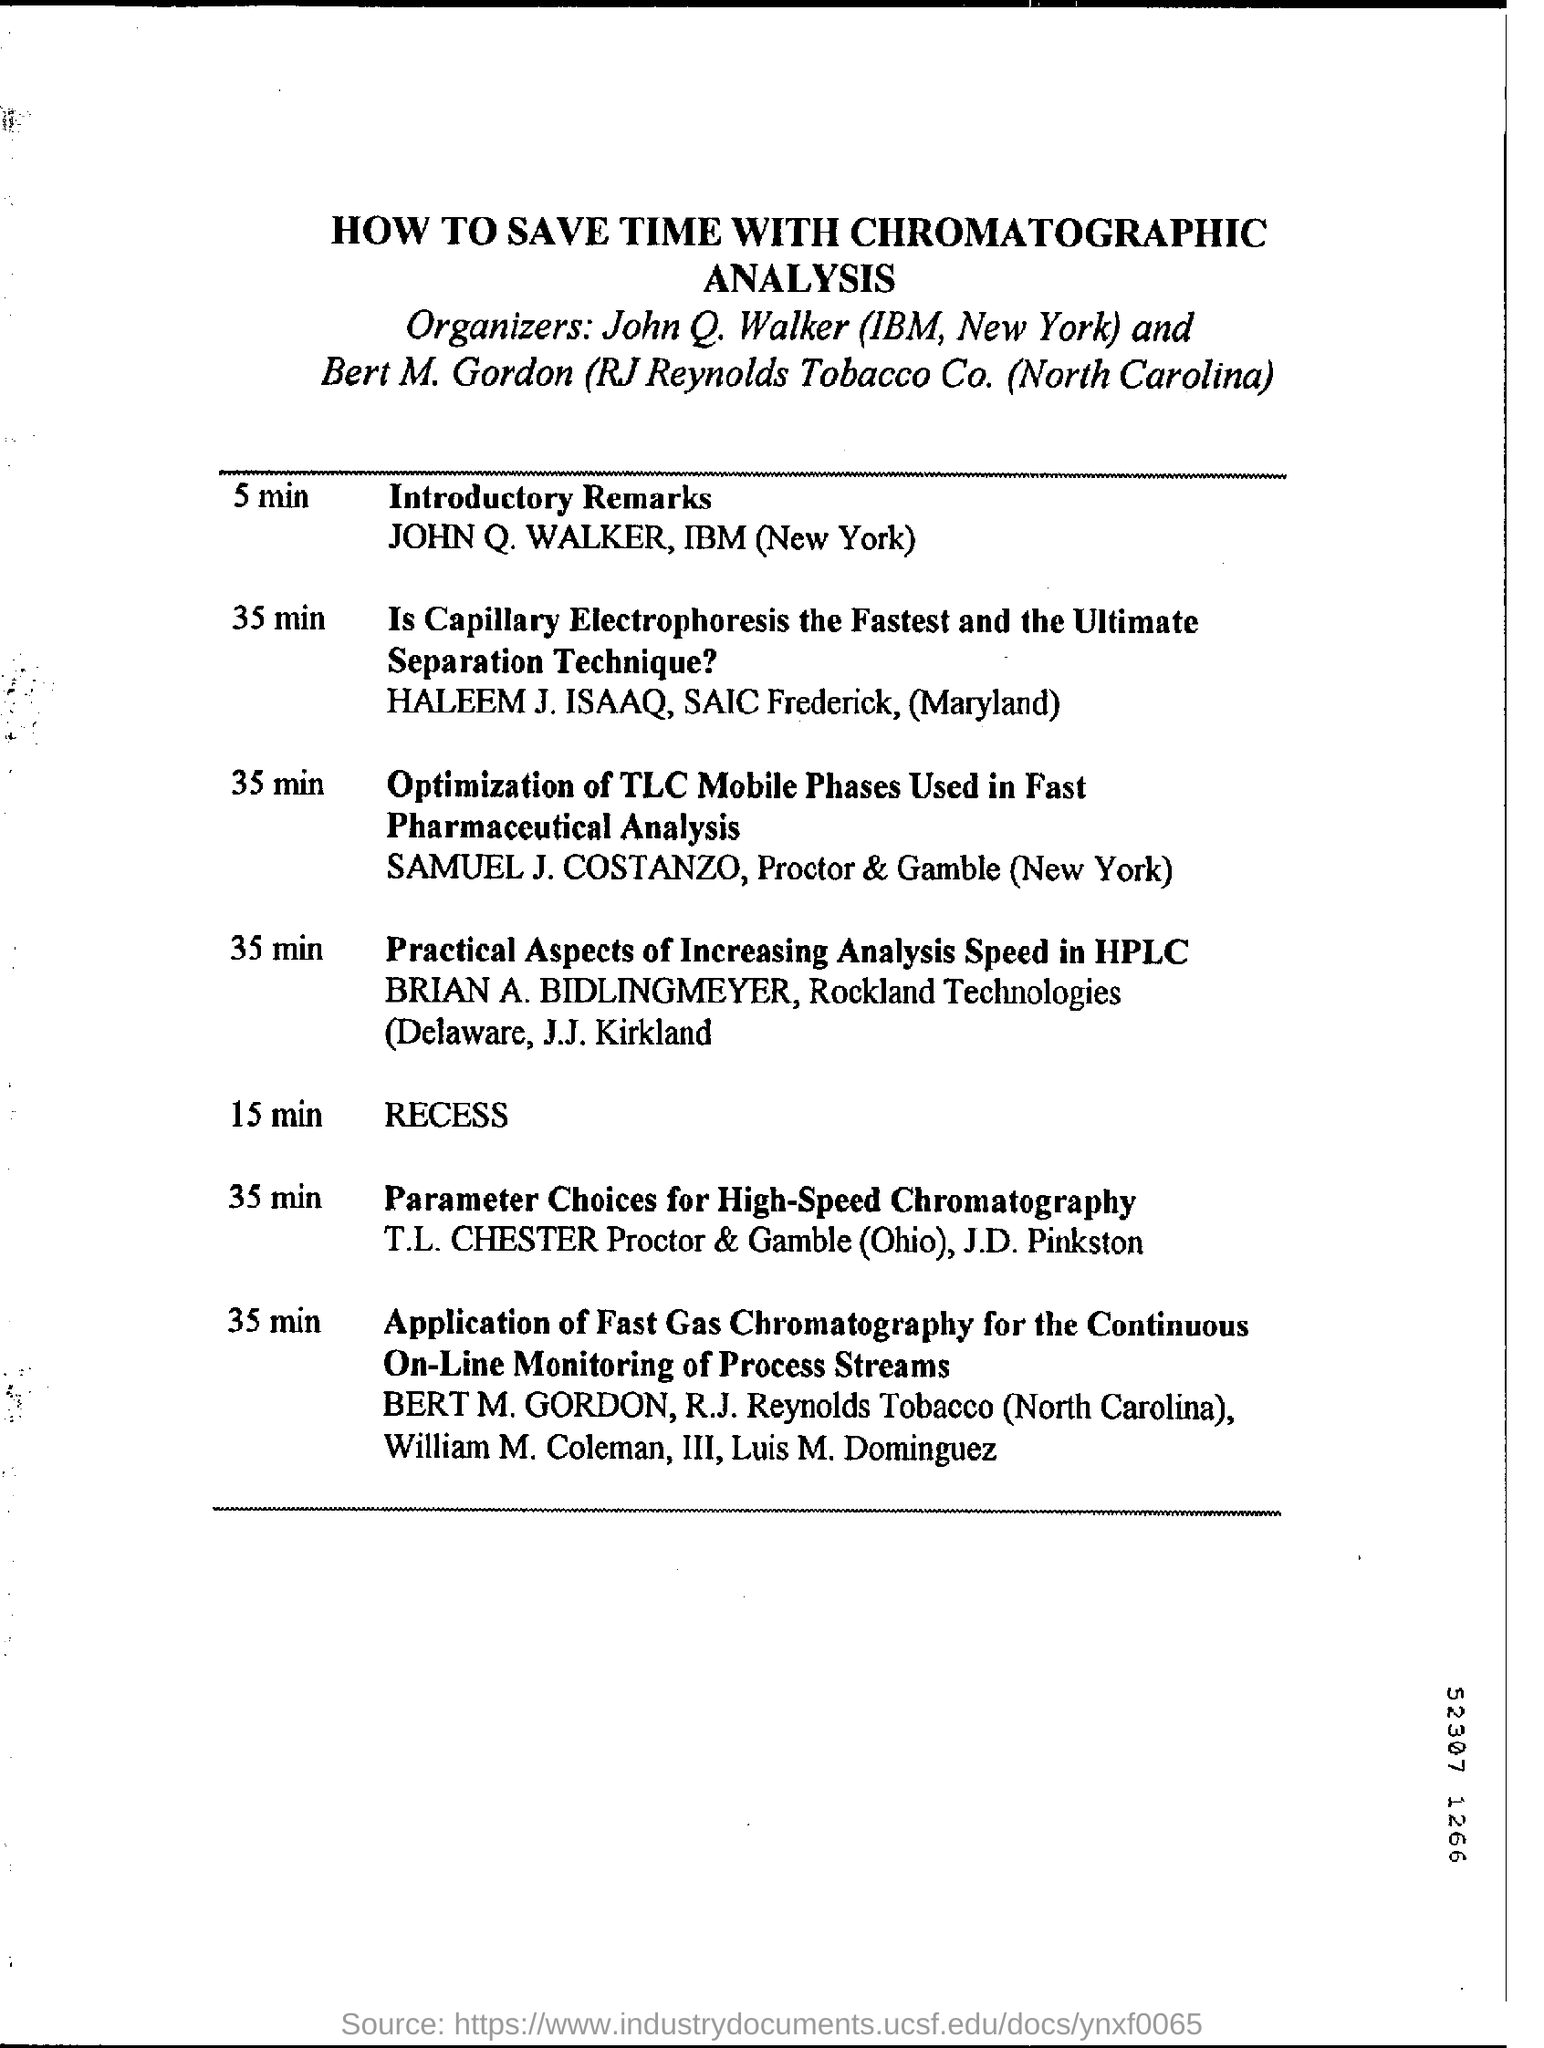Specify some key components in this picture. John Q. Walker is currently employed by IBM. 